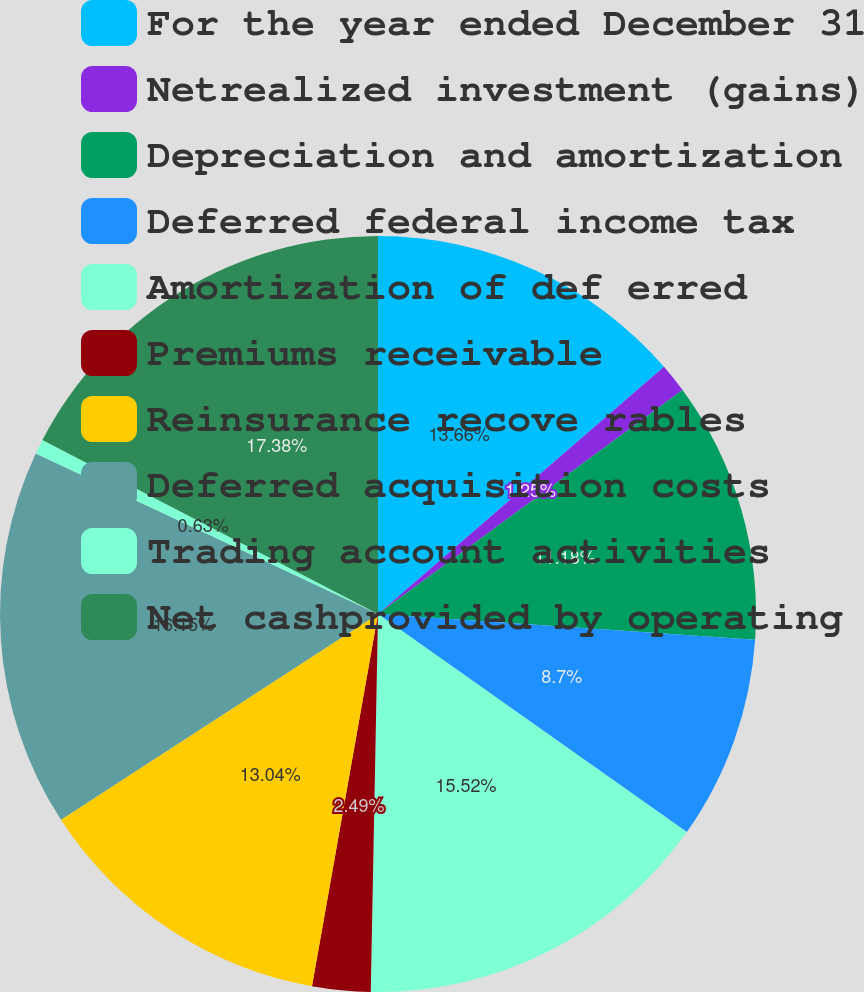<chart> <loc_0><loc_0><loc_500><loc_500><pie_chart><fcel>For the year ended December 31<fcel>Netrealized investment (gains)<fcel>Depreciation and amortization<fcel>Deferred federal income tax<fcel>Amortization of def erred<fcel>Premiums receivable<fcel>Reinsurance recove rables<fcel>Deferred acquisition costs<fcel>Trading account activities<fcel>Net cashprovided by operating<nl><fcel>13.66%<fcel>1.25%<fcel>11.18%<fcel>8.7%<fcel>15.52%<fcel>2.49%<fcel>13.04%<fcel>16.15%<fcel>0.63%<fcel>17.39%<nl></chart> 